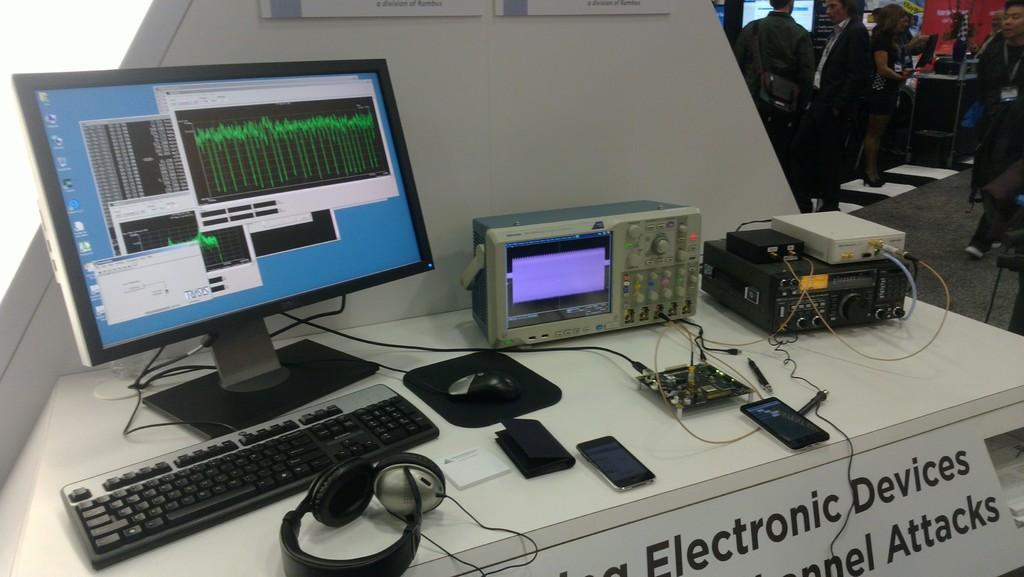Could you give a brief overview of what you see in this image? In this image we can see a table and on the table we can see a monitor, keyboard, mouse, mouse pad, headphones, mobile phones and also some other equipment. We can also see the wires, some boards. On the right we can see the people standing on the floor. We can see the wall and some other objects. 